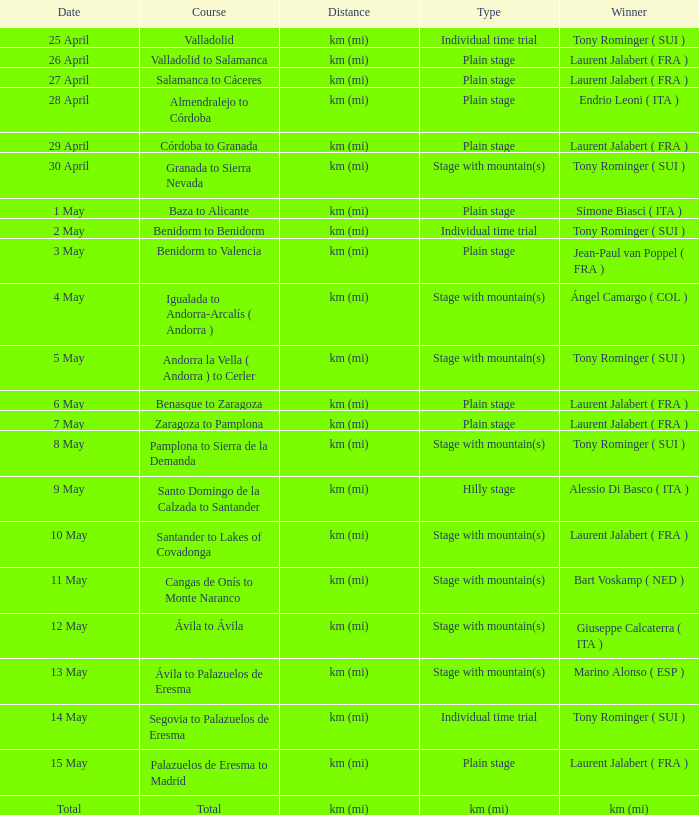What was the date when a winner was declared for kilometers (miles)? Total. 